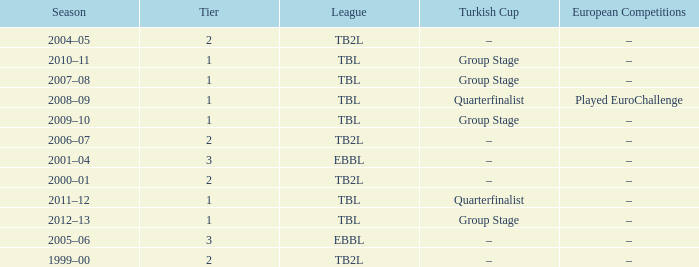Tier of 2, and a Season of 2000–01 is what European competitions? –. 